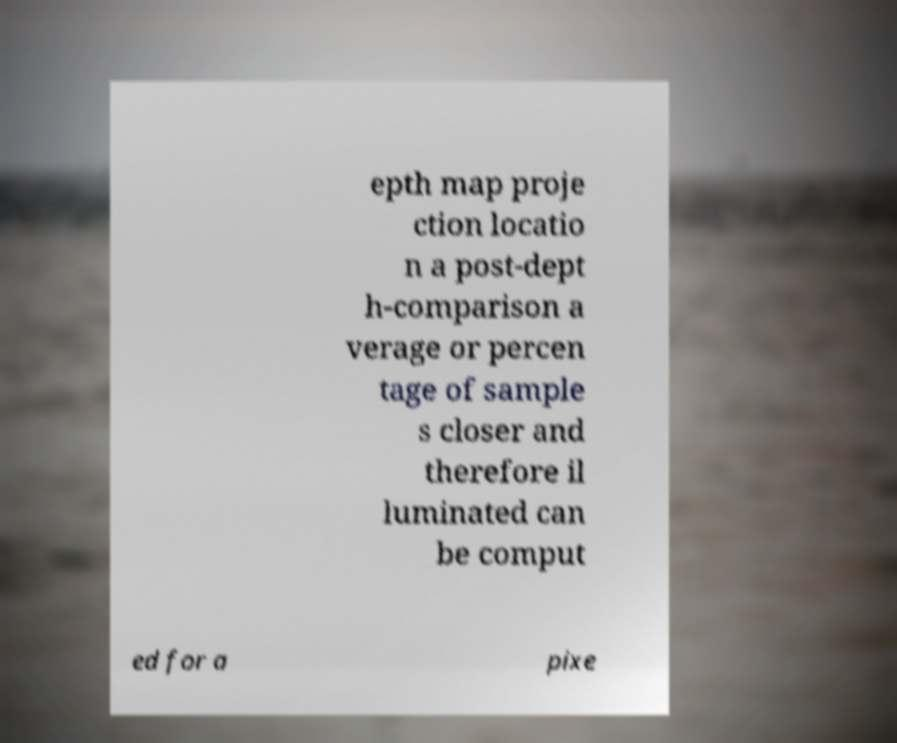Can you read and provide the text displayed in the image?This photo seems to have some interesting text. Can you extract and type it out for me? epth map proje ction locatio n a post-dept h-comparison a verage or percen tage of sample s closer and therefore il luminated can be comput ed for a pixe 